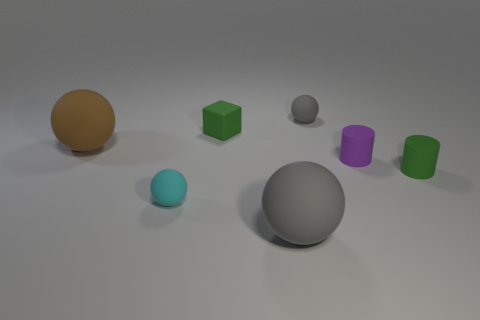There is a purple object that is the same material as the tiny green cylinder; what shape is it?
Provide a succinct answer. Cylinder. Do the small rubber object that is right of the purple matte cylinder and the large sphere that is in front of the tiny cyan ball have the same color?
Ensure brevity in your answer.  No. Are there the same number of cyan objects in front of the small cyan rubber sphere and large purple metallic balls?
Keep it short and to the point. Yes. What number of rubber cylinders are behind the purple rubber cylinder?
Make the answer very short. 0. What is the size of the brown matte ball?
Provide a short and direct response. Large. What is the color of the cube that is the same material as the large brown sphere?
Your response must be concise. Green. How many cyan matte things have the same size as the green cylinder?
Offer a terse response. 1. Is the material of the tiny sphere that is in front of the tiny purple rubber thing the same as the tiny cube?
Provide a succinct answer. Yes. Are there fewer tiny matte cylinders behind the small green cylinder than brown matte things?
Your answer should be very brief. No. What is the shape of the rubber object that is on the right side of the purple cylinder?
Ensure brevity in your answer.  Cylinder. 